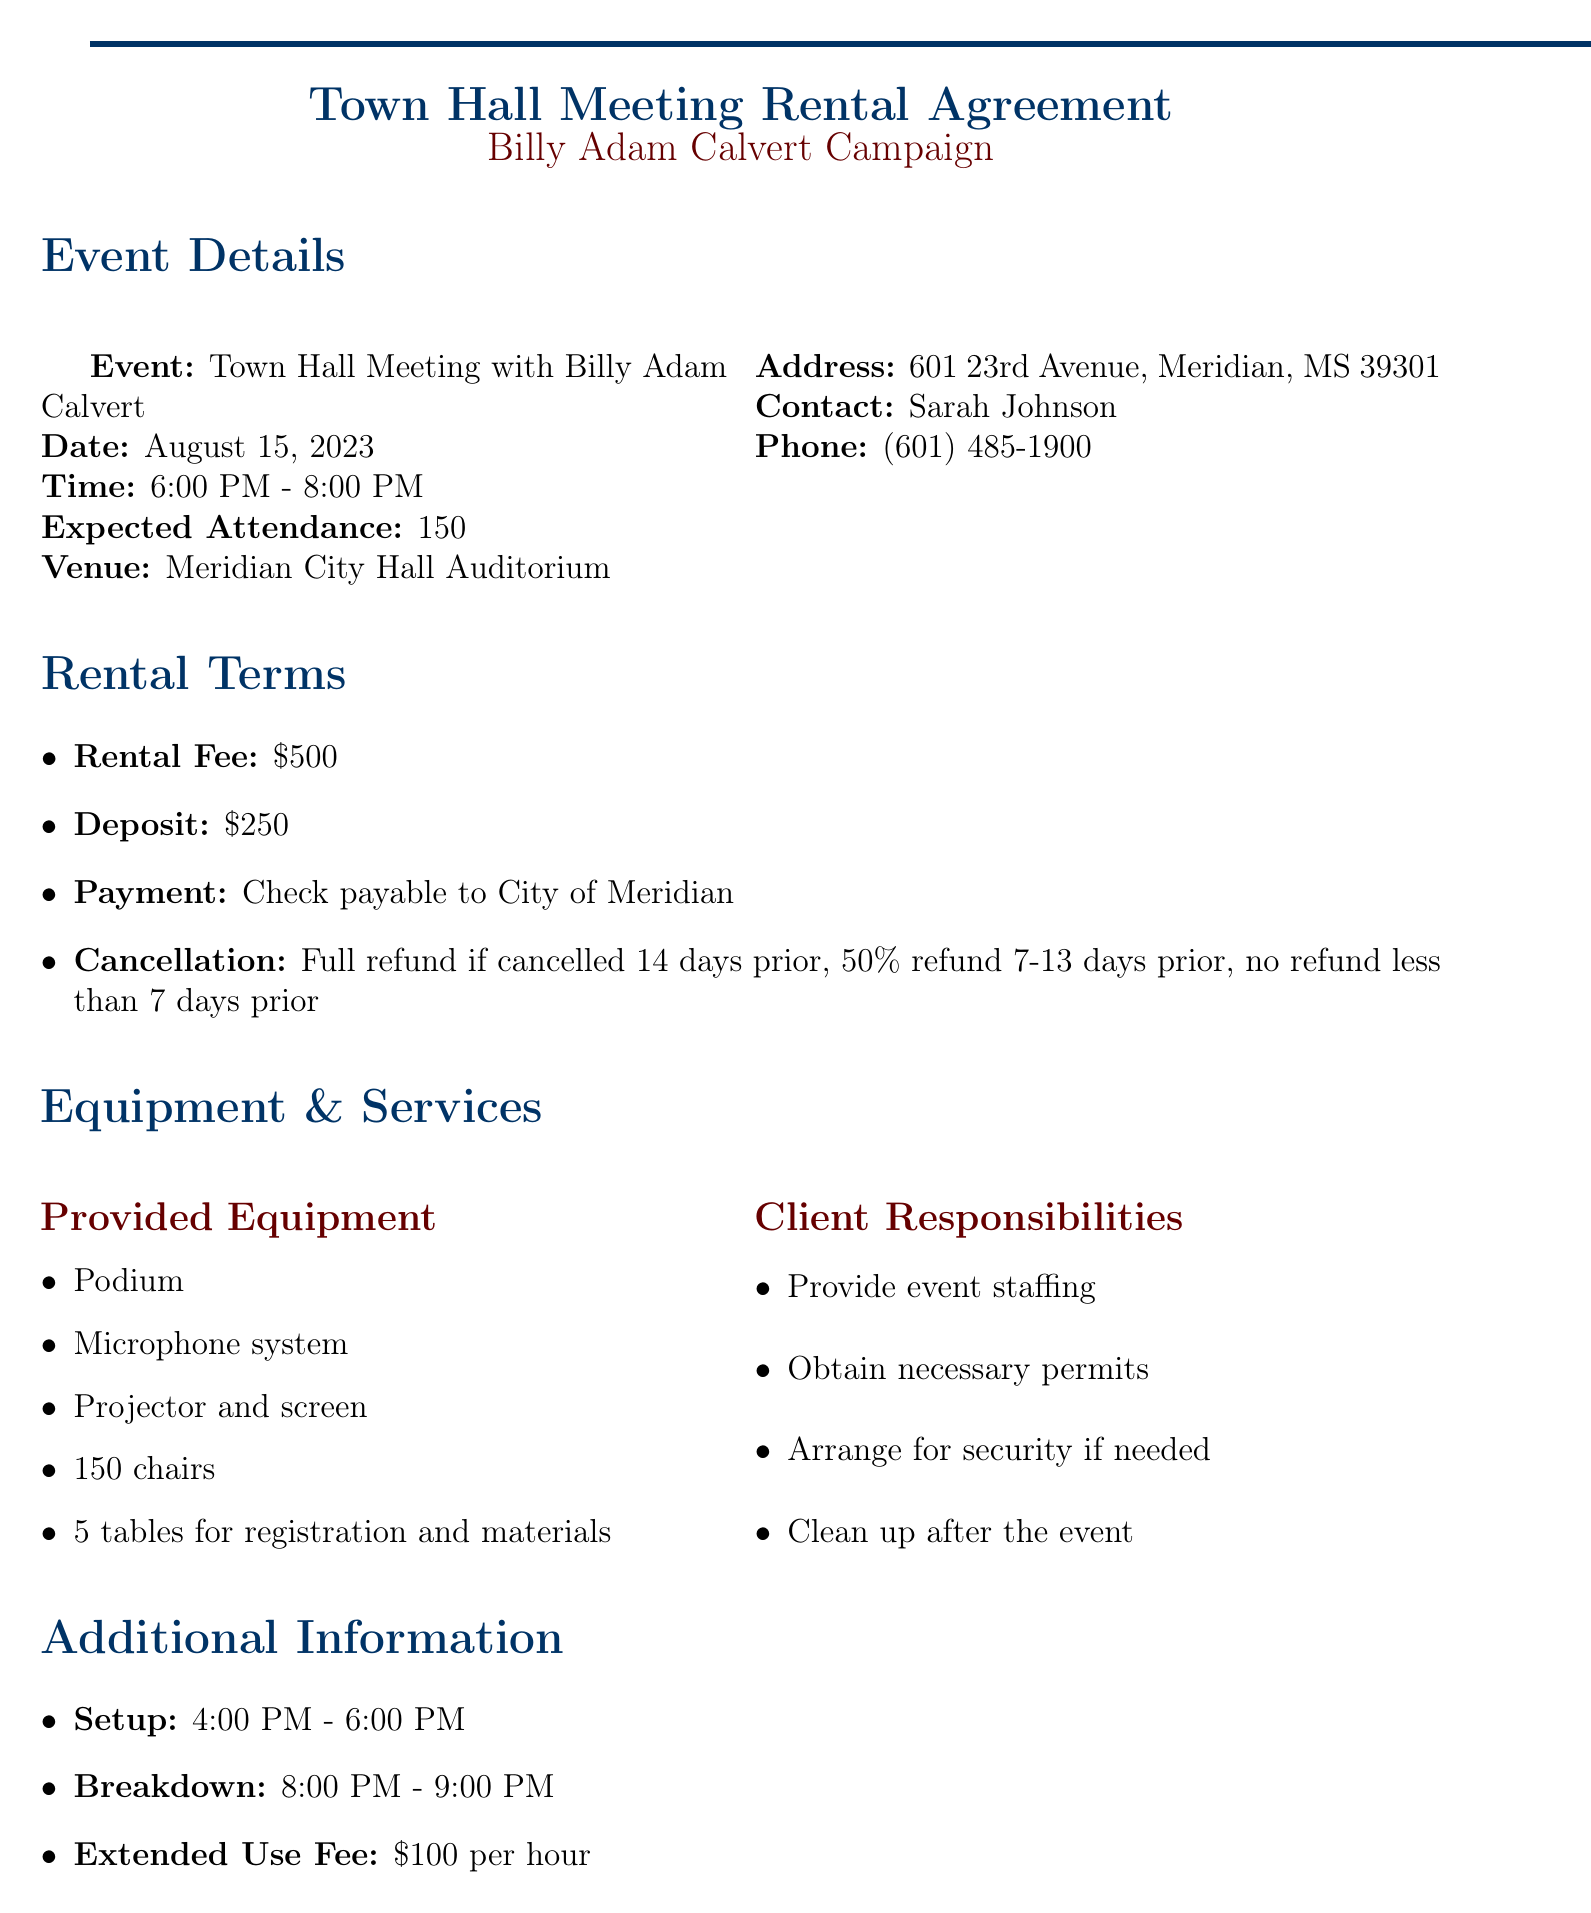What is the event name? The event name is stated in the event details section of the document.
Answer: Town Hall Meeting with Billy Adam Calvert What is the rental fee? The rental fee is specified in the rental terms section of the document.
Answer: $500 How much is the deposit amount? The deposit amount is provided in the rental terms section of the document.
Answer: $250 What is the maximum expected attendance? The expected attendance is mentioned in the event details section.
Answer: 150 What is the location of the venue? The venue's address is given in the venue information section of the document.
Answer: 601 23rd Avenue, Meridian, MS 39301 What is the cancellation policy for refunds? The cancellation policy details are outlined in the rental terms section.
Answer: Full refund if cancelled 14 days prior to event How many parking spaces are available? The number of available parking spaces is mentioned in the parking information section of the document.
Answer: 100 What is the required liability insurance amount? The liability insurance requirements are stated in the insurance requirements section.
Answer: $1,000,000 per occurrence Who is the contact person for the venue? The contact person's name is provided in the venue information section.
Answer: Sarah Johnson What are the hours for setup? The setup time is detailed in the setup and breakdown section of the document.
Answer: 4:00 PM - 6:00 PM 